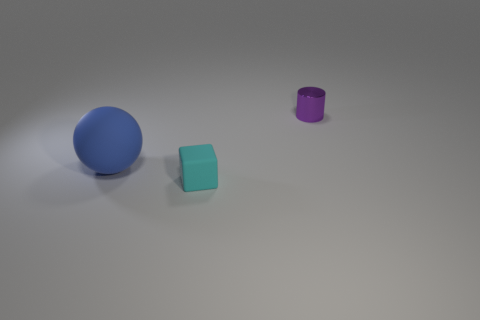What can you infer about the lighting and shadows in the scene? The lighting in the scene is soft and diffused, coming from the upper left, as indicated by the gentle shadows each object casts to the right. The shadows are soft-edged, suggesting the light source isn't extremely close. Might the choice of colors and textures have any symbolic meaning? Interpreting colors and textures symbolically can be subjective. However, one might say that the blue and purple hues could represent calmness and royalty, respectively, while the contrast in textures between matte and metallic could symbolize divergent ideas such as simplicity and complexity. 